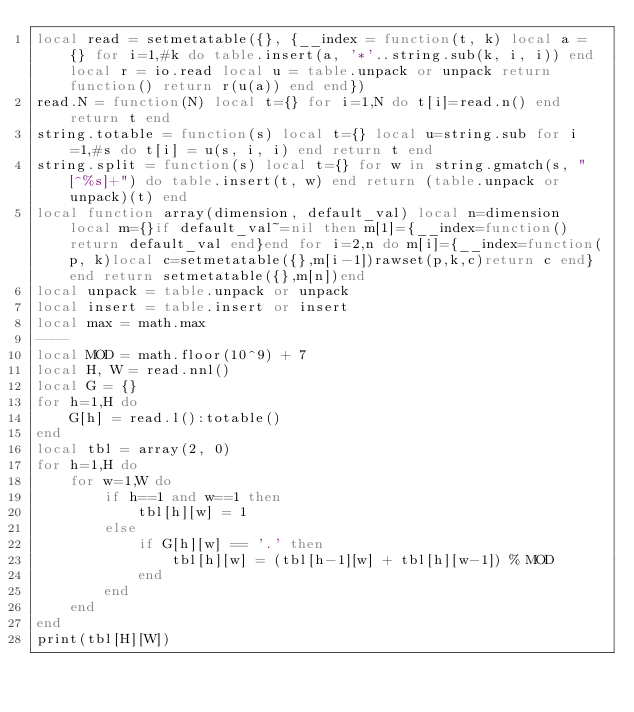<code> <loc_0><loc_0><loc_500><loc_500><_Lua_>local read = setmetatable({}, {__index = function(t, k) local a = {} for i=1,#k do table.insert(a, '*'..string.sub(k, i, i)) end local r = io.read local u = table.unpack or unpack return function() return r(u(a)) end end})
read.N = function(N) local t={} for i=1,N do t[i]=read.n() end return t end
string.totable = function(s) local t={} local u=string.sub for i=1,#s do t[i] = u(s, i, i) end return t end
string.split = function(s) local t={} for w in string.gmatch(s, "[^%s]+") do table.insert(t, w) end return (table.unpack or unpack)(t) end
local function array(dimension, default_val) local n=dimension local m={}if default_val~=nil then m[1]={__index=function()return default_val end}end for i=2,n do m[i]={__index=function(p, k)local c=setmetatable({},m[i-1])rawset(p,k,c)return c end}end return setmetatable({},m[n])end
local unpack = table.unpack or unpack
local insert = table.insert or insert
local max = math.max
----
local MOD = math.floor(10^9) + 7
local H, W = read.nnl()
local G = {}
for h=1,H do
    G[h] = read.l():totable()
end
local tbl = array(2, 0)
for h=1,H do
    for w=1,W do
        if h==1 and w==1 then
            tbl[h][w] = 1
        else
            if G[h][w] == '.' then
                tbl[h][w] = (tbl[h-1][w] + tbl[h][w-1]) % MOD
            end
        end
    end
end
print(tbl[H][W])</code> 